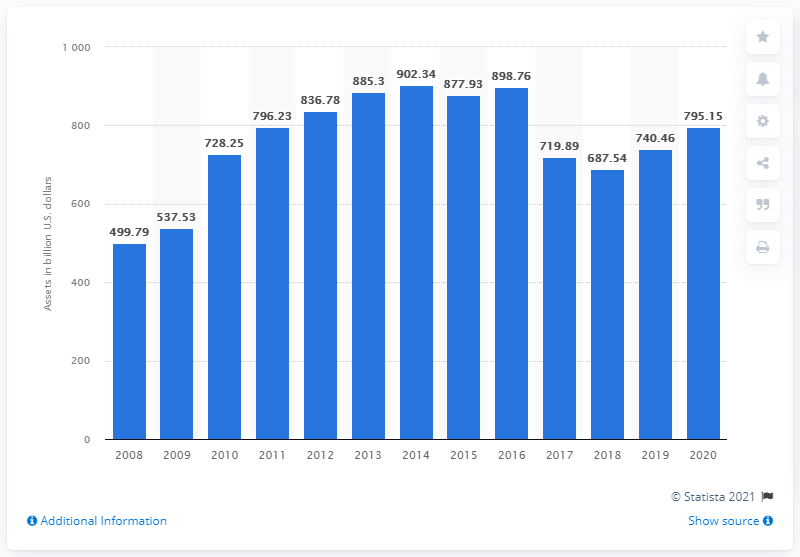Mention a couple of crucial points in this snapshot. In 2020, the total assets of MetLife were 795.15. In 2008, the total assets of MetLife were $499.79 in dollars. 